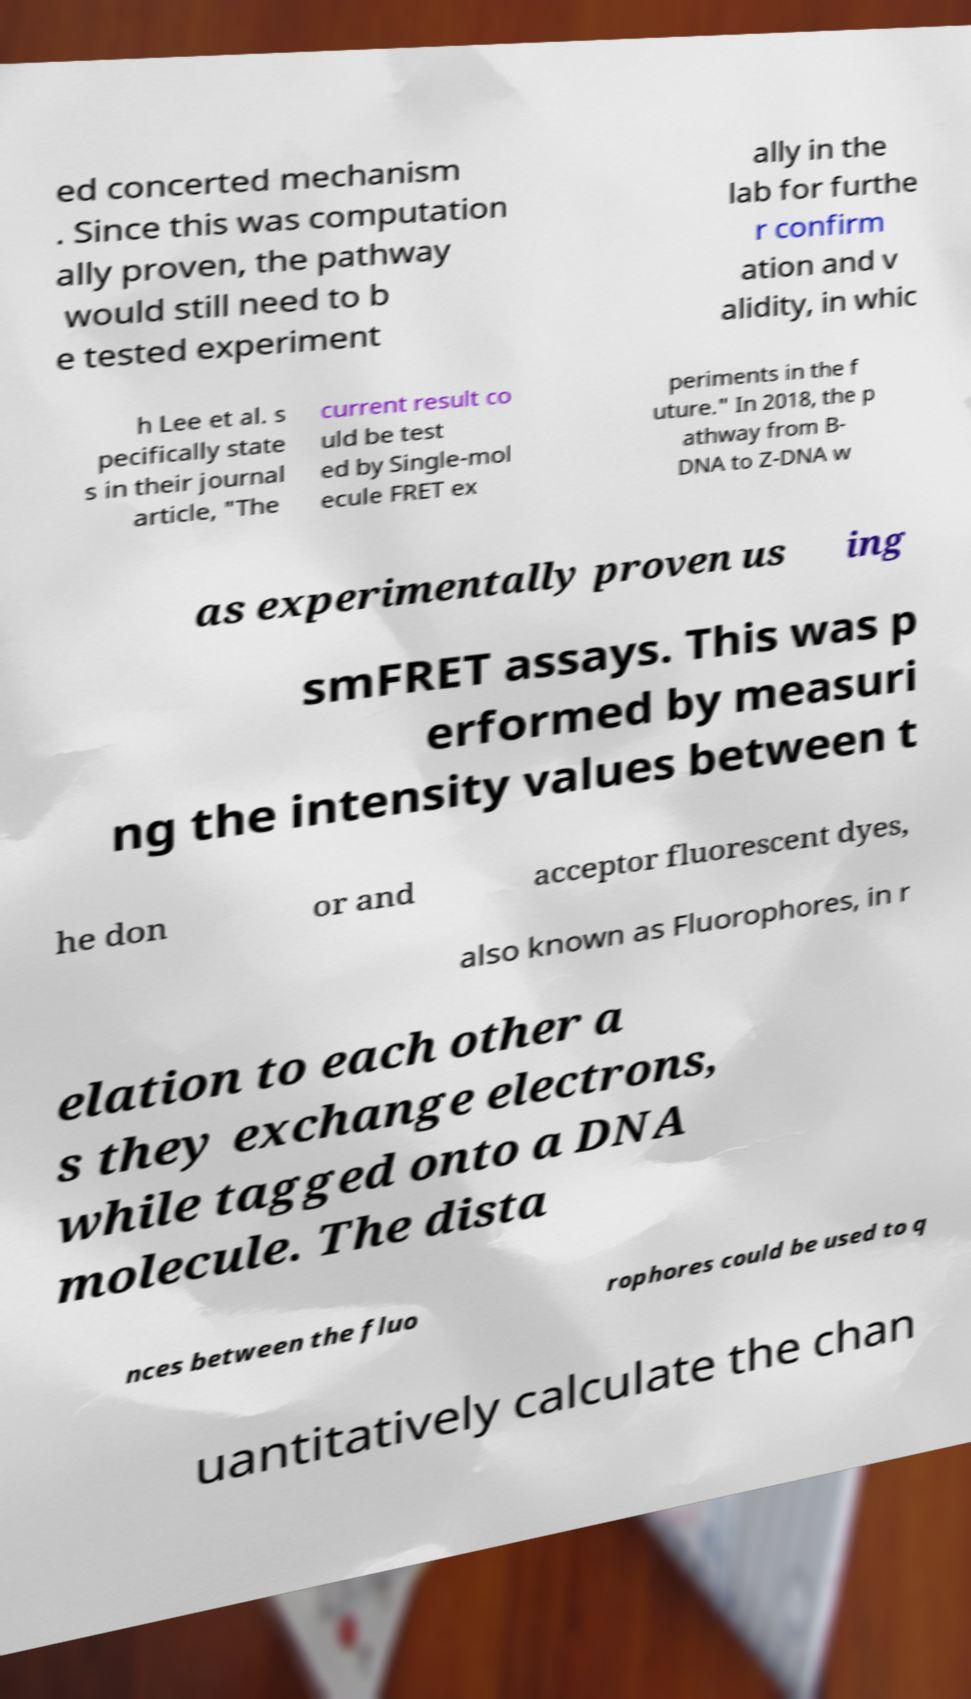I need the written content from this picture converted into text. Can you do that? ed concerted mechanism . Since this was computation ally proven, the pathway would still need to b e tested experiment ally in the lab for furthe r confirm ation and v alidity, in whic h Lee et al. s pecifically state s in their journal article, "The current result co uld be test ed by Single-mol ecule FRET ex periments in the f uture." In 2018, the p athway from B- DNA to Z-DNA w as experimentally proven us ing smFRET assays. This was p erformed by measuri ng the intensity values between t he don or and acceptor fluorescent dyes, also known as Fluorophores, in r elation to each other a s they exchange electrons, while tagged onto a DNA molecule. The dista nces between the fluo rophores could be used to q uantitatively calculate the chan 